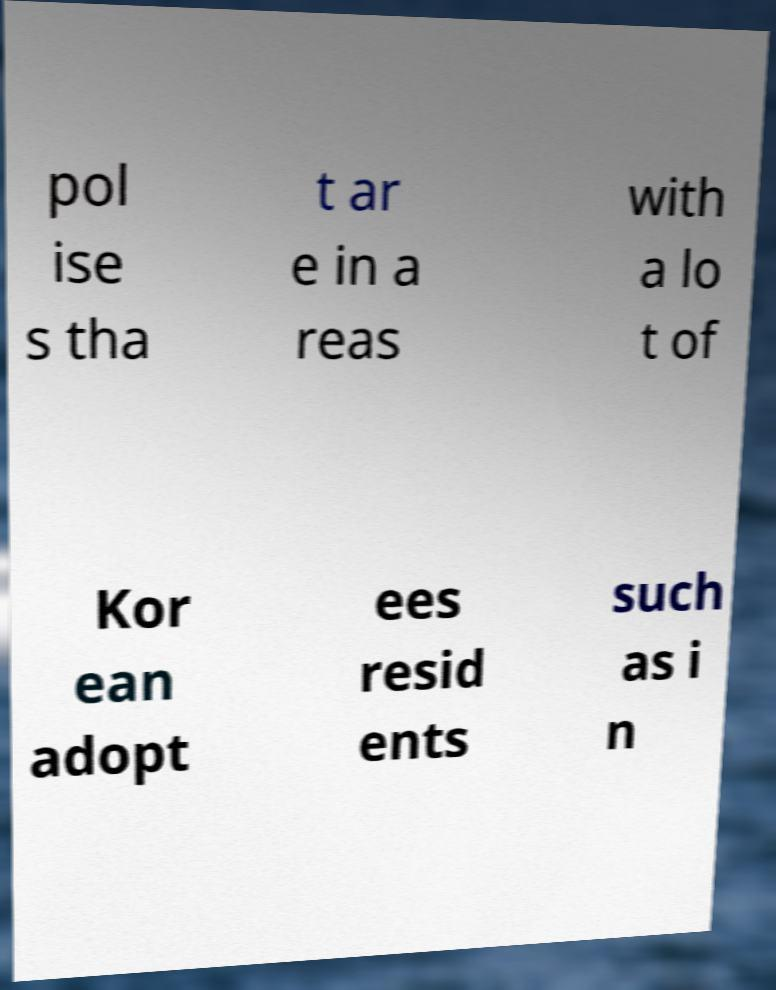Could you assist in decoding the text presented in this image and type it out clearly? pol ise s tha t ar e in a reas with a lo t of Kor ean adopt ees resid ents such as i n 